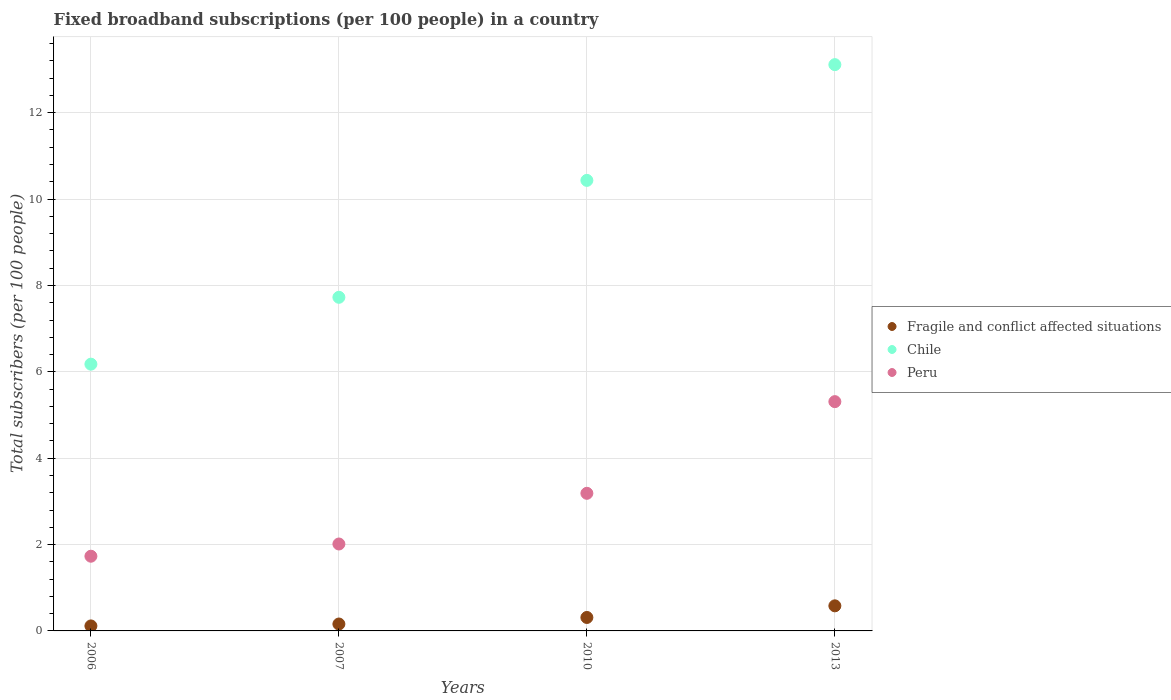How many different coloured dotlines are there?
Provide a succinct answer. 3. What is the number of broadband subscriptions in Chile in 2010?
Your answer should be very brief. 10.43. Across all years, what is the maximum number of broadband subscriptions in Peru?
Give a very brief answer. 5.31. Across all years, what is the minimum number of broadband subscriptions in Chile?
Keep it short and to the point. 6.18. In which year was the number of broadband subscriptions in Fragile and conflict affected situations minimum?
Your answer should be very brief. 2006. What is the total number of broadband subscriptions in Fragile and conflict affected situations in the graph?
Offer a very short reply. 1.17. What is the difference between the number of broadband subscriptions in Fragile and conflict affected situations in 2007 and that in 2010?
Your response must be concise. -0.15. What is the difference between the number of broadband subscriptions in Peru in 2006 and the number of broadband subscriptions in Fragile and conflict affected situations in 2007?
Offer a very short reply. 1.57. What is the average number of broadband subscriptions in Peru per year?
Offer a very short reply. 3.06. In the year 2007, what is the difference between the number of broadband subscriptions in Fragile and conflict affected situations and number of broadband subscriptions in Chile?
Provide a short and direct response. -7.57. In how many years, is the number of broadband subscriptions in Fragile and conflict affected situations greater than 3.6?
Offer a very short reply. 0. What is the ratio of the number of broadband subscriptions in Fragile and conflict affected situations in 2006 to that in 2010?
Offer a terse response. 0.37. Is the difference between the number of broadband subscriptions in Fragile and conflict affected situations in 2007 and 2010 greater than the difference between the number of broadband subscriptions in Chile in 2007 and 2010?
Offer a very short reply. Yes. What is the difference between the highest and the second highest number of broadband subscriptions in Peru?
Offer a very short reply. 2.12. What is the difference between the highest and the lowest number of broadband subscriptions in Chile?
Provide a succinct answer. 6.94. Is the number of broadband subscriptions in Fragile and conflict affected situations strictly greater than the number of broadband subscriptions in Chile over the years?
Offer a very short reply. No. How many dotlines are there?
Your response must be concise. 3. How many years are there in the graph?
Offer a very short reply. 4. What is the title of the graph?
Provide a succinct answer. Fixed broadband subscriptions (per 100 people) in a country. What is the label or title of the Y-axis?
Offer a terse response. Total subscribers (per 100 people). What is the Total subscribers (per 100 people) in Fragile and conflict affected situations in 2006?
Ensure brevity in your answer.  0.12. What is the Total subscribers (per 100 people) in Chile in 2006?
Offer a terse response. 6.18. What is the Total subscribers (per 100 people) of Peru in 2006?
Your response must be concise. 1.73. What is the Total subscribers (per 100 people) in Fragile and conflict affected situations in 2007?
Provide a succinct answer. 0.16. What is the Total subscribers (per 100 people) of Chile in 2007?
Your response must be concise. 7.73. What is the Total subscribers (per 100 people) in Peru in 2007?
Provide a short and direct response. 2.01. What is the Total subscribers (per 100 people) in Fragile and conflict affected situations in 2010?
Provide a succinct answer. 0.31. What is the Total subscribers (per 100 people) in Chile in 2010?
Ensure brevity in your answer.  10.43. What is the Total subscribers (per 100 people) in Peru in 2010?
Provide a short and direct response. 3.19. What is the Total subscribers (per 100 people) of Fragile and conflict affected situations in 2013?
Keep it short and to the point. 0.58. What is the Total subscribers (per 100 people) of Chile in 2013?
Ensure brevity in your answer.  13.11. What is the Total subscribers (per 100 people) of Peru in 2013?
Give a very brief answer. 5.31. Across all years, what is the maximum Total subscribers (per 100 people) of Fragile and conflict affected situations?
Provide a succinct answer. 0.58. Across all years, what is the maximum Total subscribers (per 100 people) in Chile?
Give a very brief answer. 13.11. Across all years, what is the maximum Total subscribers (per 100 people) of Peru?
Ensure brevity in your answer.  5.31. Across all years, what is the minimum Total subscribers (per 100 people) in Fragile and conflict affected situations?
Offer a terse response. 0.12. Across all years, what is the minimum Total subscribers (per 100 people) of Chile?
Your answer should be very brief. 6.18. Across all years, what is the minimum Total subscribers (per 100 people) in Peru?
Your answer should be compact. 1.73. What is the total Total subscribers (per 100 people) in Fragile and conflict affected situations in the graph?
Give a very brief answer. 1.17. What is the total Total subscribers (per 100 people) in Chile in the graph?
Provide a succinct answer. 37.45. What is the total Total subscribers (per 100 people) in Peru in the graph?
Keep it short and to the point. 12.24. What is the difference between the Total subscribers (per 100 people) of Fragile and conflict affected situations in 2006 and that in 2007?
Give a very brief answer. -0.04. What is the difference between the Total subscribers (per 100 people) in Chile in 2006 and that in 2007?
Your answer should be compact. -1.55. What is the difference between the Total subscribers (per 100 people) of Peru in 2006 and that in 2007?
Ensure brevity in your answer.  -0.28. What is the difference between the Total subscribers (per 100 people) of Fragile and conflict affected situations in 2006 and that in 2010?
Give a very brief answer. -0.2. What is the difference between the Total subscribers (per 100 people) in Chile in 2006 and that in 2010?
Keep it short and to the point. -4.26. What is the difference between the Total subscribers (per 100 people) in Peru in 2006 and that in 2010?
Your answer should be compact. -1.46. What is the difference between the Total subscribers (per 100 people) in Fragile and conflict affected situations in 2006 and that in 2013?
Give a very brief answer. -0.47. What is the difference between the Total subscribers (per 100 people) of Chile in 2006 and that in 2013?
Provide a succinct answer. -6.94. What is the difference between the Total subscribers (per 100 people) in Peru in 2006 and that in 2013?
Give a very brief answer. -3.58. What is the difference between the Total subscribers (per 100 people) of Fragile and conflict affected situations in 2007 and that in 2010?
Make the answer very short. -0.15. What is the difference between the Total subscribers (per 100 people) of Chile in 2007 and that in 2010?
Give a very brief answer. -2.71. What is the difference between the Total subscribers (per 100 people) of Peru in 2007 and that in 2010?
Make the answer very short. -1.17. What is the difference between the Total subscribers (per 100 people) of Fragile and conflict affected situations in 2007 and that in 2013?
Provide a short and direct response. -0.42. What is the difference between the Total subscribers (per 100 people) in Chile in 2007 and that in 2013?
Give a very brief answer. -5.39. What is the difference between the Total subscribers (per 100 people) of Peru in 2007 and that in 2013?
Ensure brevity in your answer.  -3.3. What is the difference between the Total subscribers (per 100 people) in Fragile and conflict affected situations in 2010 and that in 2013?
Give a very brief answer. -0.27. What is the difference between the Total subscribers (per 100 people) in Chile in 2010 and that in 2013?
Your answer should be very brief. -2.68. What is the difference between the Total subscribers (per 100 people) in Peru in 2010 and that in 2013?
Offer a terse response. -2.12. What is the difference between the Total subscribers (per 100 people) of Fragile and conflict affected situations in 2006 and the Total subscribers (per 100 people) of Chile in 2007?
Make the answer very short. -7.61. What is the difference between the Total subscribers (per 100 people) of Fragile and conflict affected situations in 2006 and the Total subscribers (per 100 people) of Peru in 2007?
Offer a very short reply. -1.9. What is the difference between the Total subscribers (per 100 people) in Chile in 2006 and the Total subscribers (per 100 people) in Peru in 2007?
Offer a terse response. 4.16. What is the difference between the Total subscribers (per 100 people) of Fragile and conflict affected situations in 2006 and the Total subscribers (per 100 people) of Chile in 2010?
Ensure brevity in your answer.  -10.32. What is the difference between the Total subscribers (per 100 people) of Fragile and conflict affected situations in 2006 and the Total subscribers (per 100 people) of Peru in 2010?
Give a very brief answer. -3.07. What is the difference between the Total subscribers (per 100 people) of Chile in 2006 and the Total subscribers (per 100 people) of Peru in 2010?
Make the answer very short. 2.99. What is the difference between the Total subscribers (per 100 people) of Fragile and conflict affected situations in 2006 and the Total subscribers (per 100 people) of Chile in 2013?
Provide a succinct answer. -13. What is the difference between the Total subscribers (per 100 people) in Fragile and conflict affected situations in 2006 and the Total subscribers (per 100 people) in Peru in 2013?
Your answer should be very brief. -5.19. What is the difference between the Total subscribers (per 100 people) in Chile in 2006 and the Total subscribers (per 100 people) in Peru in 2013?
Provide a short and direct response. 0.87. What is the difference between the Total subscribers (per 100 people) of Fragile and conflict affected situations in 2007 and the Total subscribers (per 100 people) of Chile in 2010?
Your response must be concise. -10.27. What is the difference between the Total subscribers (per 100 people) in Fragile and conflict affected situations in 2007 and the Total subscribers (per 100 people) in Peru in 2010?
Offer a very short reply. -3.03. What is the difference between the Total subscribers (per 100 people) in Chile in 2007 and the Total subscribers (per 100 people) in Peru in 2010?
Offer a terse response. 4.54. What is the difference between the Total subscribers (per 100 people) in Fragile and conflict affected situations in 2007 and the Total subscribers (per 100 people) in Chile in 2013?
Give a very brief answer. -12.95. What is the difference between the Total subscribers (per 100 people) of Fragile and conflict affected situations in 2007 and the Total subscribers (per 100 people) of Peru in 2013?
Keep it short and to the point. -5.15. What is the difference between the Total subscribers (per 100 people) of Chile in 2007 and the Total subscribers (per 100 people) of Peru in 2013?
Ensure brevity in your answer.  2.42. What is the difference between the Total subscribers (per 100 people) of Fragile and conflict affected situations in 2010 and the Total subscribers (per 100 people) of Chile in 2013?
Ensure brevity in your answer.  -12.8. What is the difference between the Total subscribers (per 100 people) of Fragile and conflict affected situations in 2010 and the Total subscribers (per 100 people) of Peru in 2013?
Your answer should be compact. -5. What is the difference between the Total subscribers (per 100 people) in Chile in 2010 and the Total subscribers (per 100 people) in Peru in 2013?
Give a very brief answer. 5.12. What is the average Total subscribers (per 100 people) in Fragile and conflict affected situations per year?
Keep it short and to the point. 0.29. What is the average Total subscribers (per 100 people) of Chile per year?
Provide a succinct answer. 9.36. What is the average Total subscribers (per 100 people) of Peru per year?
Your answer should be very brief. 3.06. In the year 2006, what is the difference between the Total subscribers (per 100 people) in Fragile and conflict affected situations and Total subscribers (per 100 people) in Chile?
Keep it short and to the point. -6.06. In the year 2006, what is the difference between the Total subscribers (per 100 people) of Fragile and conflict affected situations and Total subscribers (per 100 people) of Peru?
Provide a short and direct response. -1.61. In the year 2006, what is the difference between the Total subscribers (per 100 people) of Chile and Total subscribers (per 100 people) of Peru?
Ensure brevity in your answer.  4.45. In the year 2007, what is the difference between the Total subscribers (per 100 people) in Fragile and conflict affected situations and Total subscribers (per 100 people) in Chile?
Make the answer very short. -7.57. In the year 2007, what is the difference between the Total subscribers (per 100 people) of Fragile and conflict affected situations and Total subscribers (per 100 people) of Peru?
Offer a terse response. -1.85. In the year 2007, what is the difference between the Total subscribers (per 100 people) in Chile and Total subscribers (per 100 people) in Peru?
Give a very brief answer. 5.71. In the year 2010, what is the difference between the Total subscribers (per 100 people) of Fragile and conflict affected situations and Total subscribers (per 100 people) of Chile?
Offer a very short reply. -10.12. In the year 2010, what is the difference between the Total subscribers (per 100 people) of Fragile and conflict affected situations and Total subscribers (per 100 people) of Peru?
Provide a succinct answer. -2.88. In the year 2010, what is the difference between the Total subscribers (per 100 people) of Chile and Total subscribers (per 100 people) of Peru?
Provide a succinct answer. 7.25. In the year 2013, what is the difference between the Total subscribers (per 100 people) of Fragile and conflict affected situations and Total subscribers (per 100 people) of Chile?
Make the answer very short. -12.53. In the year 2013, what is the difference between the Total subscribers (per 100 people) in Fragile and conflict affected situations and Total subscribers (per 100 people) in Peru?
Provide a succinct answer. -4.73. In the year 2013, what is the difference between the Total subscribers (per 100 people) of Chile and Total subscribers (per 100 people) of Peru?
Your answer should be compact. 7.8. What is the ratio of the Total subscribers (per 100 people) in Fragile and conflict affected situations in 2006 to that in 2007?
Provide a succinct answer. 0.72. What is the ratio of the Total subscribers (per 100 people) in Chile in 2006 to that in 2007?
Make the answer very short. 0.8. What is the ratio of the Total subscribers (per 100 people) in Peru in 2006 to that in 2007?
Your answer should be compact. 0.86. What is the ratio of the Total subscribers (per 100 people) of Fragile and conflict affected situations in 2006 to that in 2010?
Your response must be concise. 0.37. What is the ratio of the Total subscribers (per 100 people) of Chile in 2006 to that in 2010?
Offer a terse response. 0.59. What is the ratio of the Total subscribers (per 100 people) in Peru in 2006 to that in 2010?
Your answer should be very brief. 0.54. What is the ratio of the Total subscribers (per 100 people) in Fragile and conflict affected situations in 2006 to that in 2013?
Your answer should be very brief. 0.2. What is the ratio of the Total subscribers (per 100 people) of Chile in 2006 to that in 2013?
Provide a short and direct response. 0.47. What is the ratio of the Total subscribers (per 100 people) of Peru in 2006 to that in 2013?
Offer a terse response. 0.33. What is the ratio of the Total subscribers (per 100 people) in Fragile and conflict affected situations in 2007 to that in 2010?
Provide a short and direct response. 0.51. What is the ratio of the Total subscribers (per 100 people) in Chile in 2007 to that in 2010?
Provide a succinct answer. 0.74. What is the ratio of the Total subscribers (per 100 people) in Peru in 2007 to that in 2010?
Your response must be concise. 0.63. What is the ratio of the Total subscribers (per 100 people) in Fragile and conflict affected situations in 2007 to that in 2013?
Your answer should be very brief. 0.28. What is the ratio of the Total subscribers (per 100 people) of Chile in 2007 to that in 2013?
Make the answer very short. 0.59. What is the ratio of the Total subscribers (per 100 people) of Peru in 2007 to that in 2013?
Your response must be concise. 0.38. What is the ratio of the Total subscribers (per 100 people) in Fragile and conflict affected situations in 2010 to that in 2013?
Offer a terse response. 0.54. What is the ratio of the Total subscribers (per 100 people) of Chile in 2010 to that in 2013?
Keep it short and to the point. 0.8. What is the ratio of the Total subscribers (per 100 people) of Peru in 2010 to that in 2013?
Ensure brevity in your answer.  0.6. What is the difference between the highest and the second highest Total subscribers (per 100 people) of Fragile and conflict affected situations?
Keep it short and to the point. 0.27. What is the difference between the highest and the second highest Total subscribers (per 100 people) of Chile?
Give a very brief answer. 2.68. What is the difference between the highest and the second highest Total subscribers (per 100 people) of Peru?
Your answer should be very brief. 2.12. What is the difference between the highest and the lowest Total subscribers (per 100 people) of Fragile and conflict affected situations?
Provide a short and direct response. 0.47. What is the difference between the highest and the lowest Total subscribers (per 100 people) in Chile?
Provide a succinct answer. 6.94. What is the difference between the highest and the lowest Total subscribers (per 100 people) of Peru?
Give a very brief answer. 3.58. 